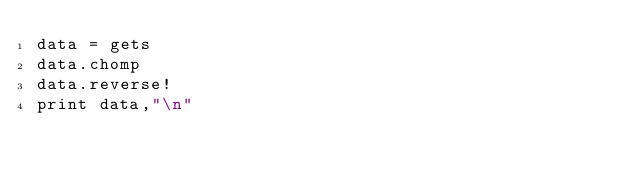Convert code to text. <code><loc_0><loc_0><loc_500><loc_500><_Ruby_>data = gets
data.chomp
data.reverse!
print data,"\n"</code> 